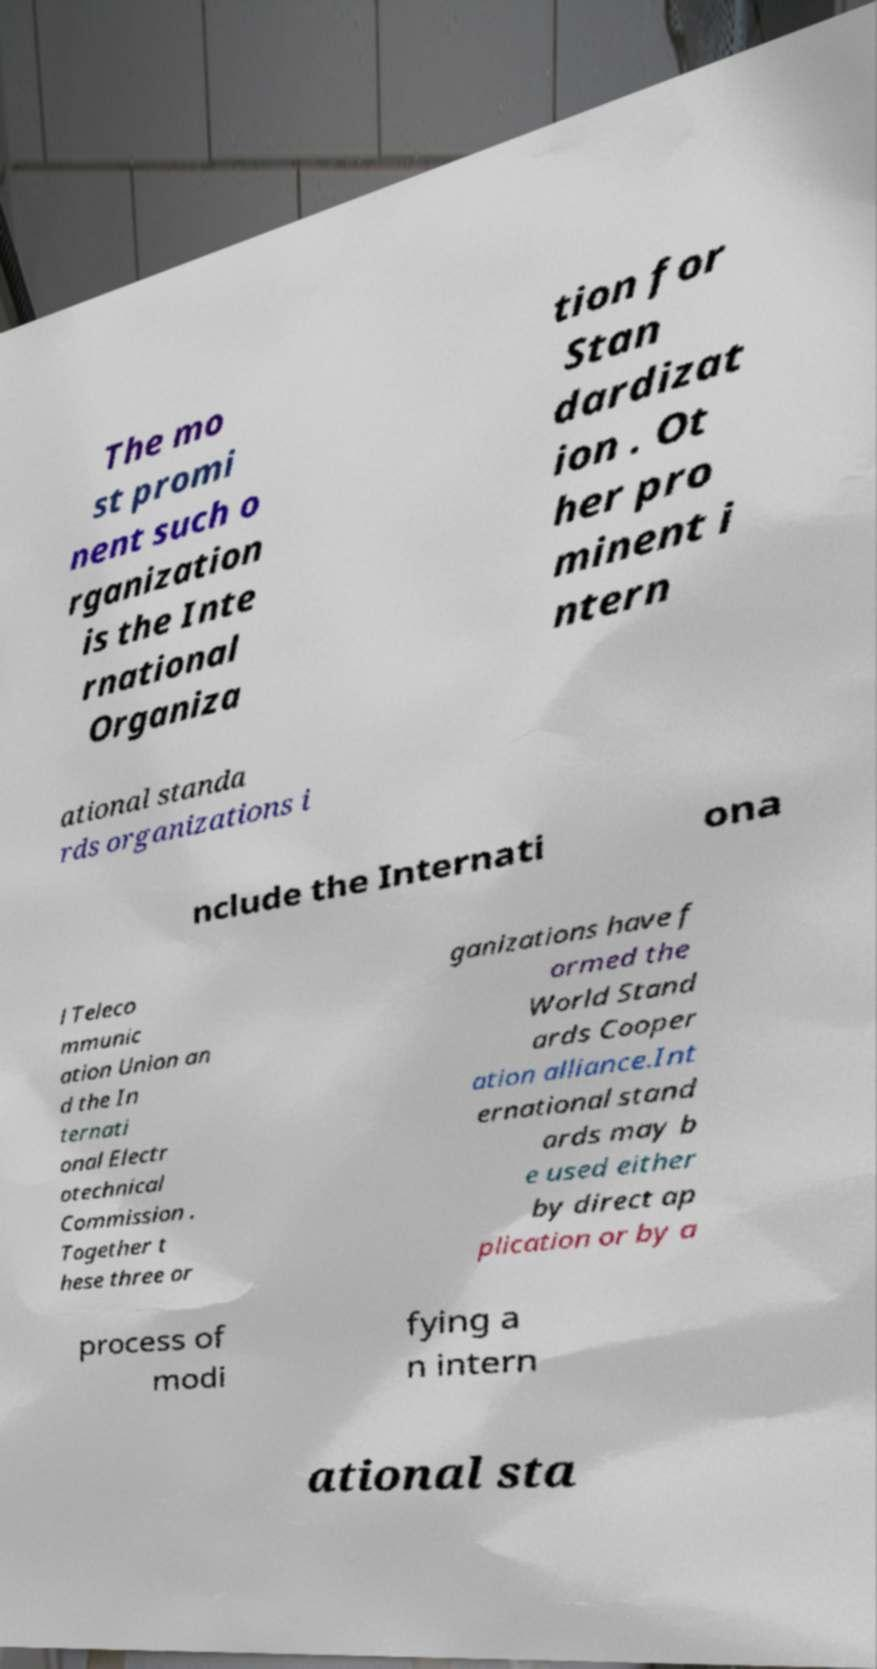Can you read and provide the text displayed in the image?This photo seems to have some interesting text. Can you extract and type it out for me? The mo st promi nent such o rganization is the Inte rnational Organiza tion for Stan dardizat ion . Ot her pro minent i ntern ational standa rds organizations i nclude the Internati ona l Teleco mmunic ation Union an d the In ternati onal Electr otechnical Commission . Together t hese three or ganizations have f ormed the World Stand ards Cooper ation alliance.Int ernational stand ards may b e used either by direct ap plication or by a process of modi fying a n intern ational sta 